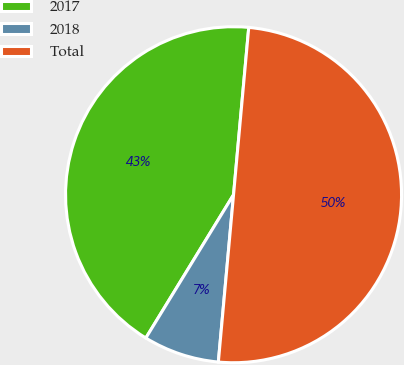<chart> <loc_0><loc_0><loc_500><loc_500><pie_chart><fcel>2017<fcel>2018<fcel>Total<nl><fcel>42.7%<fcel>7.3%<fcel>50.0%<nl></chart> 